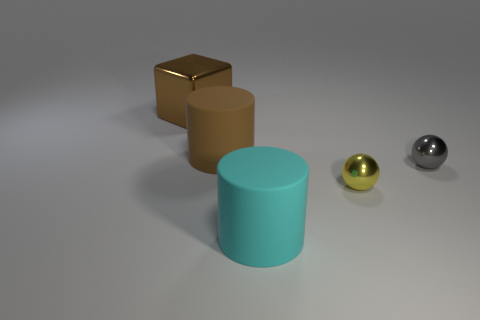There is a big rubber object that is left of the large cyan rubber object; is its color the same as the large object that is behind the brown cylinder?
Provide a short and direct response. Yes. What number of shiny things are both behind the brown rubber cylinder and in front of the big brown cylinder?
Provide a succinct answer. 0. What size is the object that is made of the same material as the brown cylinder?
Your response must be concise. Large. The brown matte cylinder has what size?
Offer a terse response. Large. What material is the big brown cylinder?
Offer a terse response. Rubber. There is a rubber object in front of the yellow thing; is it the same size as the large brown cylinder?
Offer a terse response. Yes. What number of things are blue metallic balls or large brown matte objects?
Your answer should be very brief. 1. There is a object that is the same color as the big metallic block; what is its shape?
Make the answer very short. Cylinder. There is a thing that is both on the left side of the yellow metal thing and in front of the gray metallic sphere; what size is it?
Make the answer very short. Large. What number of big brown rubber objects are there?
Make the answer very short. 1. 